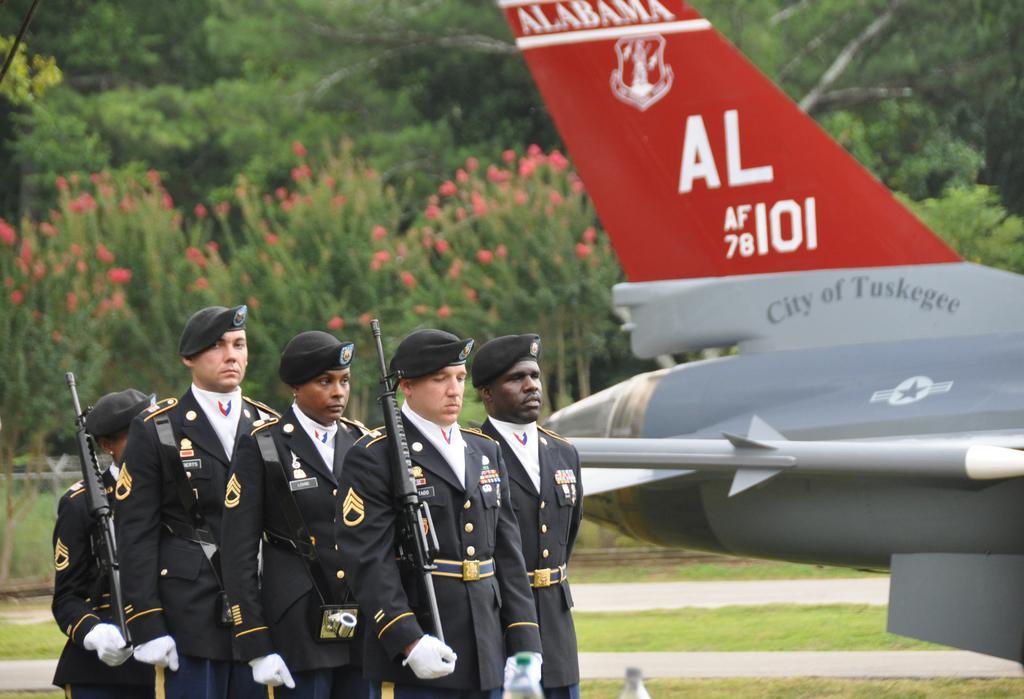In one or two sentences, can you explain what this image depicts? This image consists of five persons wearing black dresses and black caps. Two persons are holding the guns. At the bottom, there is green grass on the ground. On the right, we can see an aircraft. In the background, there are plants and trees along with flowers. 